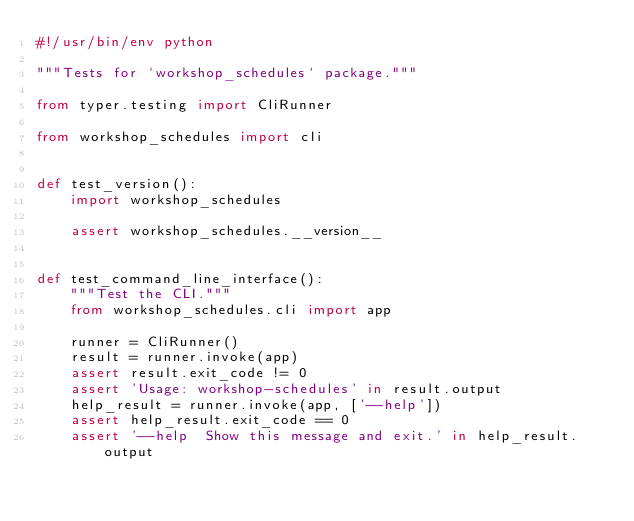Convert code to text. <code><loc_0><loc_0><loc_500><loc_500><_Python_>#!/usr/bin/env python

"""Tests for `workshop_schedules` package."""

from typer.testing import CliRunner

from workshop_schedules import cli


def test_version():
    import workshop_schedules

    assert workshop_schedules.__version__


def test_command_line_interface():
    """Test the CLI."""
    from workshop_schedules.cli import app

    runner = CliRunner()
    result = runner.invoke(app)
    assert result.exit_code != 0
    assert 'Usage: workshop-schedules' in result.output
    help_result = runner.invoke(app, ['--help'])
    assert help_result.exit_code == 0
    assert '--help  Show this message and exit.' in help_result.output
</code> 